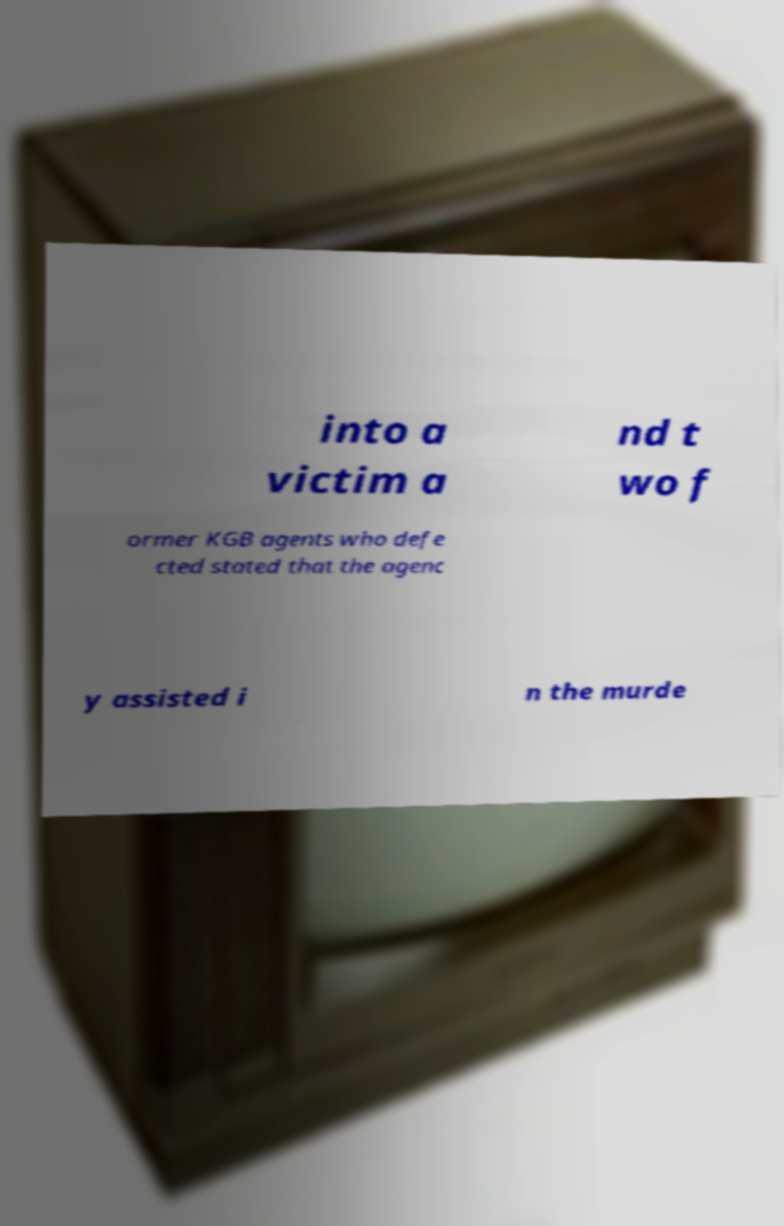I need the written content from this picture converted into text. Can you do that? into a victim a nd t wo f ormer KGB agents who defe cted stated that the agenc y assisted i n the murde 